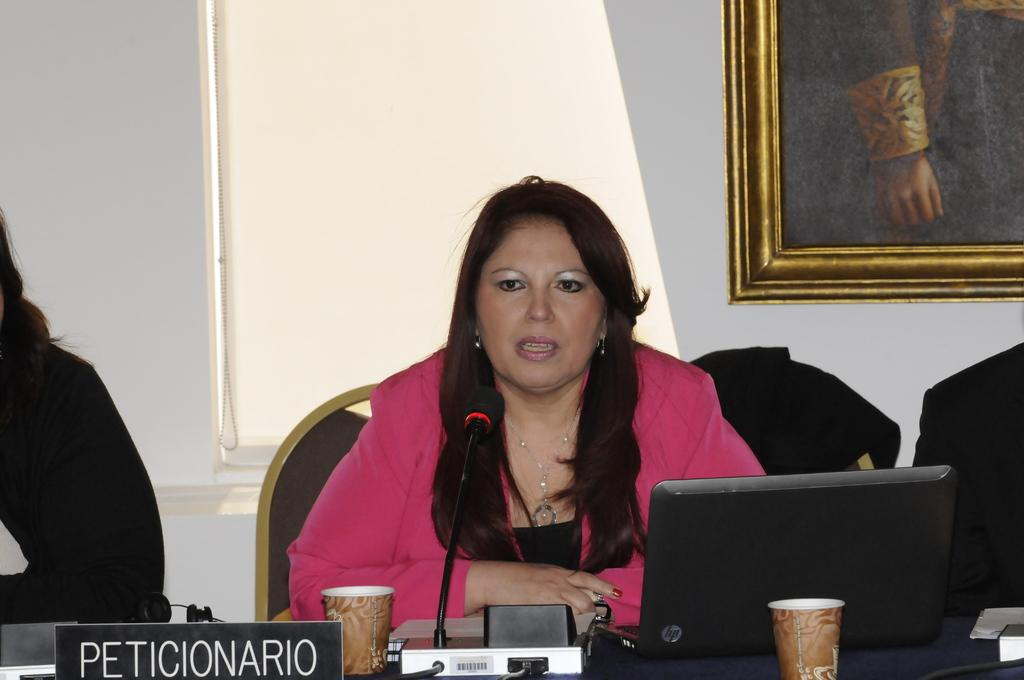What is the man in the image doing? The man is seated and speaking in the image. What object is the man holding? The man is holding a microphone. What can be seen on the table in the image? There is a laptop and a glass on the table. Can you see any eggs being kicked around in the image? There are no eggs or kicking activity present in the image. 